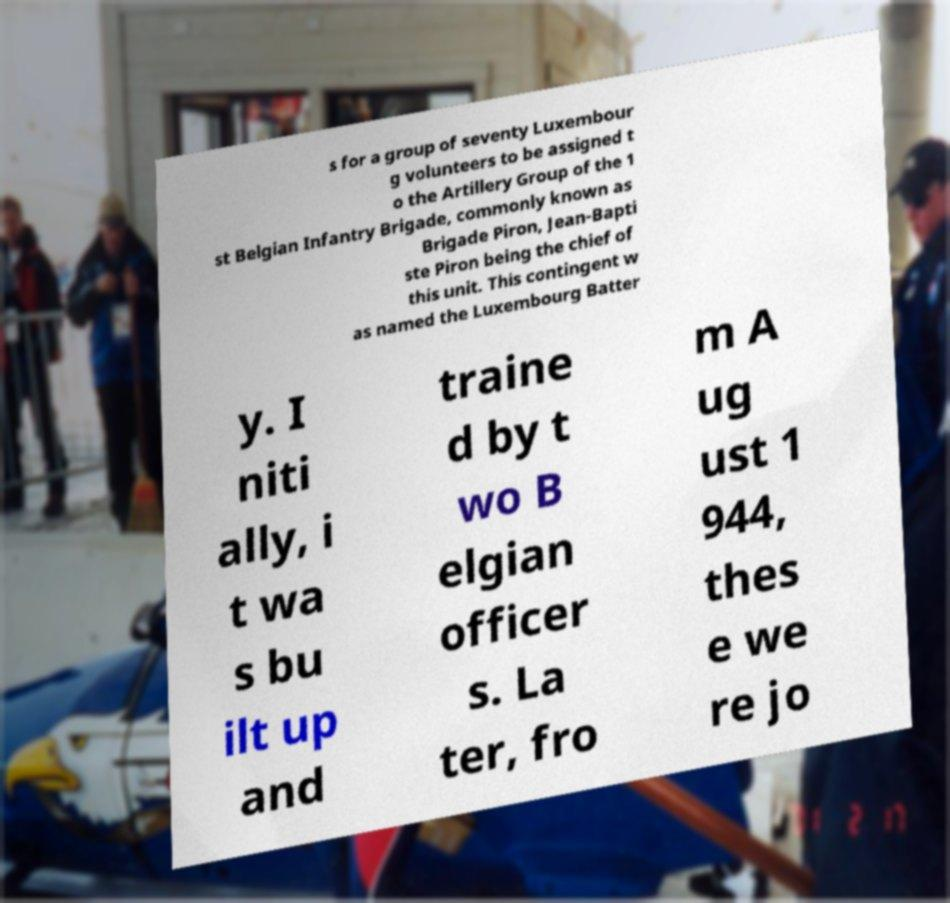Can you accurately transcribe the text from the provided image for me? s for a group of seventy Luxembour g volunteers to be assigned t o the Artillery Group of the 1 st Belgian Infantry Brigade, commonly known as Brigade Piron, Jean-Bapti ste Piron being the chief of this unit. This contingent w as named the Luxembourg Batter y. I niti ally, i t wa s bu ilt up and traine d by t wo B elgian officer s. La ter, fro m A ug ust 1 944, thes e we re jo 